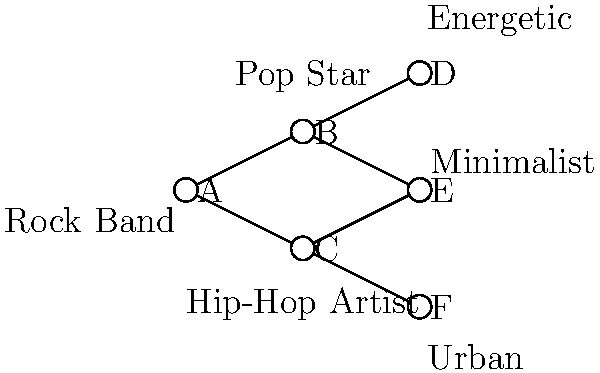As a creative director, you're tasked with matching artists to suitable album cover designs. Given the network diagram representing relationships between artists (A, B, C) and design styles (D, E, F), which design style would be most appropriate for the Hip-Hop Artist? To determine the most appropriate design style for the Hip-Hop Artist, let's analyze the network diagram step-by-step:

1. Identify the artists:
   A: Rock Band
   B: Pop Star
   C: Hip-Hop Artist

2. Identify the design styles:
   D: Energetic
   E: Minimalist
   F: Urban

3. Examine the connections:
   - The Hip-Hop Artist (C) is directly connected to two design styles: E (Minimalist) and F (Urban).
   - There is no direct connection between the Hip-Hop Artist and D (Energetic).

4. Consider the artist's genre:
   - Hip-hop music is often associated with urban culture and street art.
   - The Urban design style (F) aligns more closely with the hip-hop aesthetic than the Minimalist style (E).

5. Evaluate the options:
   - While a minimalist design could work for some hip-hop albums, the Urban style is generally more representative of the genre.
   - The Urban design style likely incorporates elements of street art, graffiti, or city landscapes, which are common themes in hip-hop culture.

6. Make the connection:
   - The direct link between C (Hip-Hop Artist) and F (Urban) in the diagram supports this choice.

Therefore, based on the network diagram and the typical associations of hip-hop music, the most appropriate design style for the Hip-Hop Artist would be F (Urban).
Answer: Urban (F) 